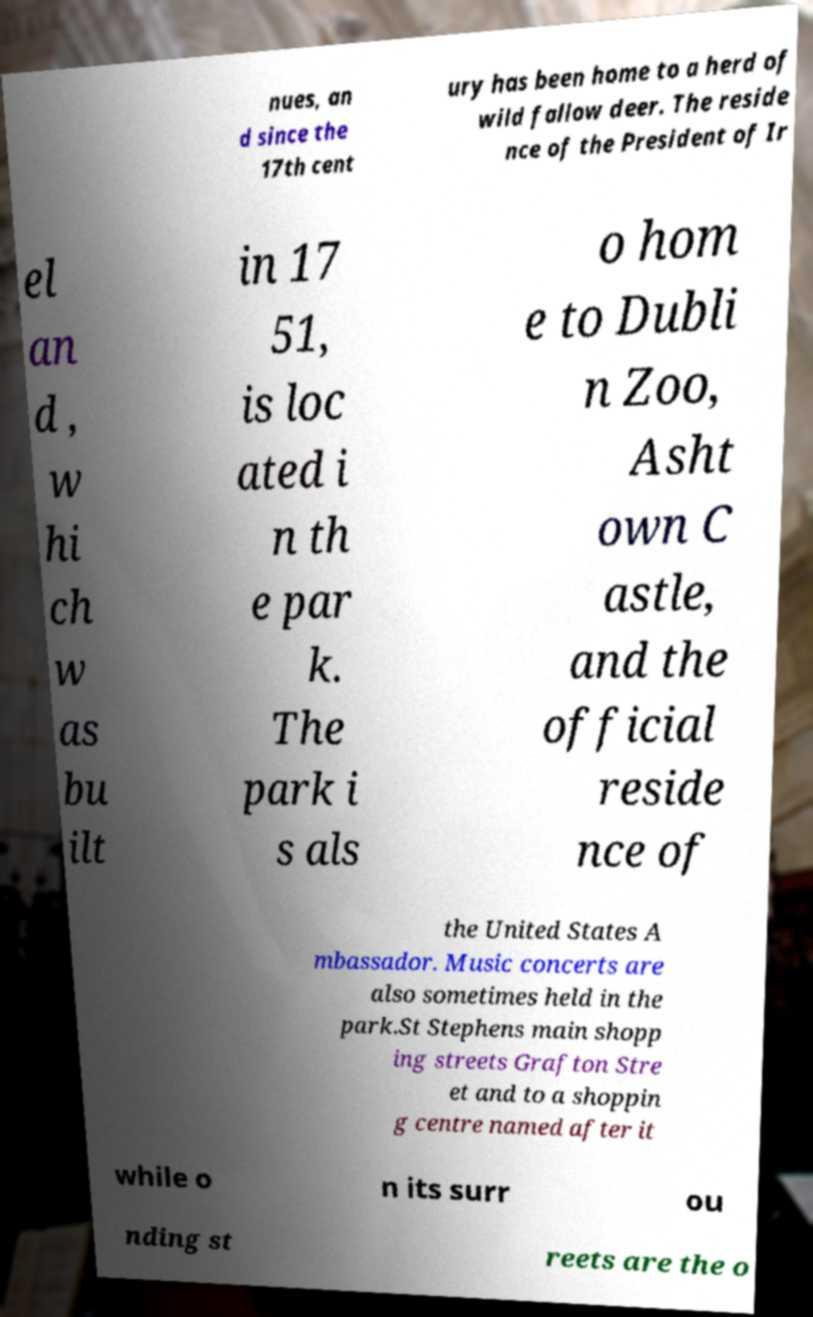Could you assist in decoding the text presented in this image and type it out clearly? nues, an d since the 17th cent ury has been home to a herd of wild fallow deer. The reside nce of the President of Ir el an d , w hi ch w as bu ilt in 17 51, is loc ated i n th e par k. The park i s als o hom e to Dubli n Zoo, Asht own C astle, and the official reside nce of the United States A mbassador. Music concerts are also sometimes held in the park.St Stephens main shopp ing streets Grafton Stre et and to a shoppin g centre named after it while o n its surr ou nding st reets are the o 